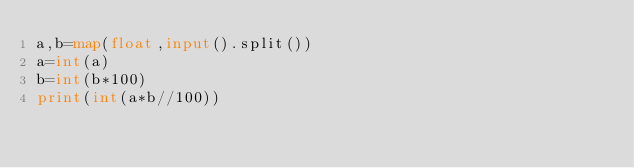<code> <loc_0><loc_0><loc_500><loc_500><_Python_>a,b=map(float,input().split())
a=int(a)
b=int(b*100)
print(int(a*b//100))</code> 